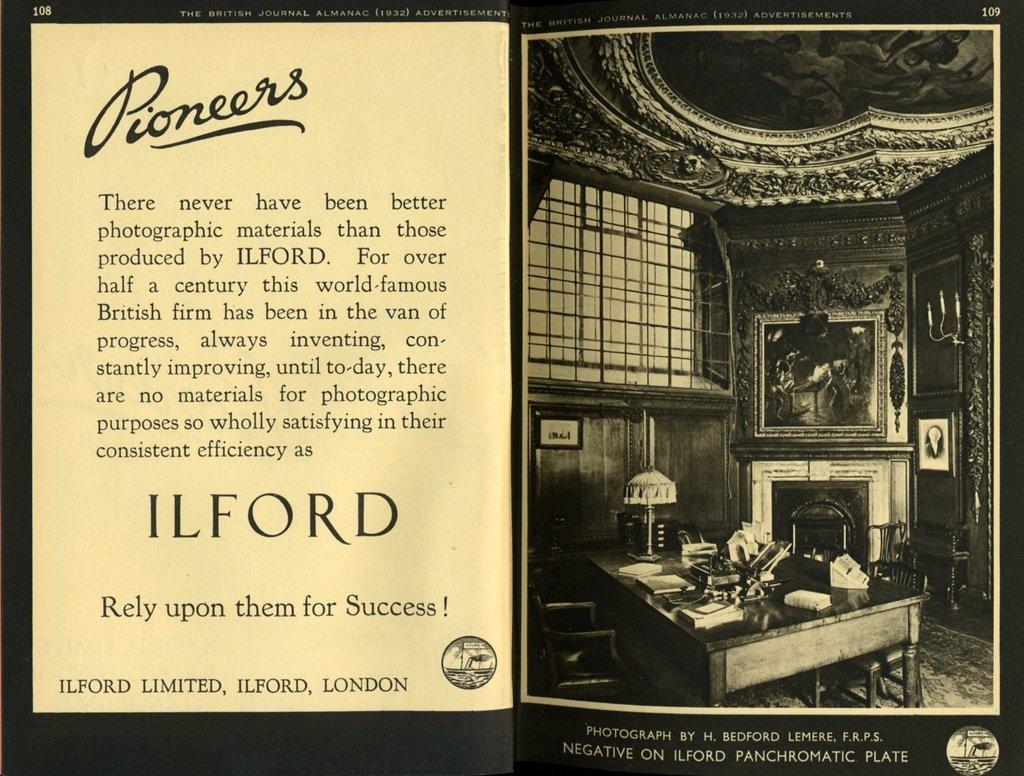According to this advertisement "there never have been better photographic materials than those produced by" who?
Give a very brief answer. Ilford. What city is this company located in?
Offer a terse response. London. 